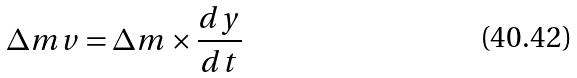Convert formula to latex. <formula><loc_0><loc_0><loc_500><loc_500>\Delta m v = \Delta m \times \frac { d y } { d t }</formula> 